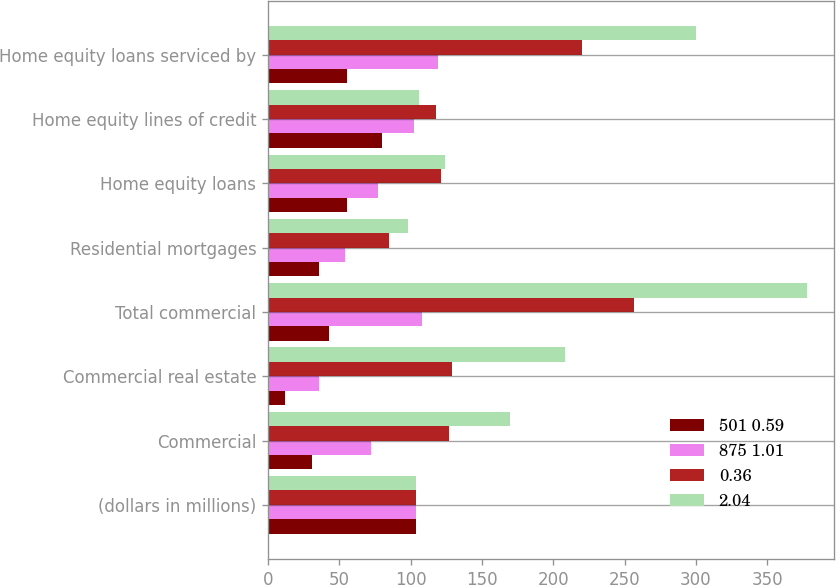Convert chart to OTSL. <chart><loc_0><loc_0><loc_500><loc_500><stacked_bar_chart><ecel><fcel>(dollars in millions)<fcel>Commercial<fcel>Commercial real estate<fcel>Total commercial<fcel>Residential mortgages<fcel>Home equity loans<fcel>Home equity lines of credit<fcel>Home equity loans serviced by<nl><fcel>501 0.59<fcel>104<fcel>31<fcel>12<fcel>43<fcel>36<fcel>55<fcel>80<fcel>55<nl><fcel>875 1.01<fcel>104<fcel>72<fcel>36<fcel>108<fcel>54<fcel>77<fcel>102<fcel>119<nl><fcel>0.36<fcel>104<fcel>127<fcel>129<fcel>257<fcel>85<fcel>121<fcel>118<fcel>220<nl><fcel>2.04<fcel>104<fcel>170<fcel>208<fcel>378<fcel>98<fcel>124<fcel>106<fcel>300<nl></chart> 